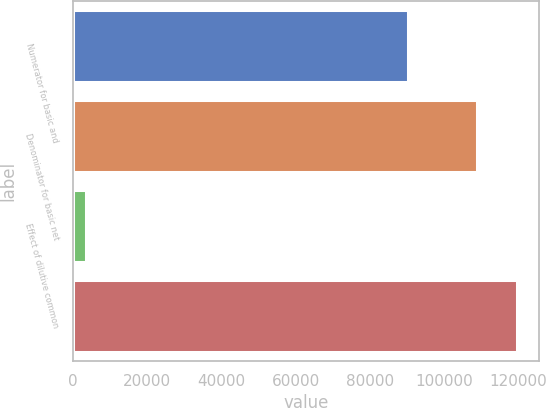Convert chart. <chart><loc_0><loc_0><loc_500><loc_500><bar_chart><fcel>Numerator for basic and<fcel>Denominator for basic net<fcel>Effect of dilutive common<fcel>Unnamed: 3<nl><fcel>90313<fcel>108815<fcel>3460<fcel>119696<nl></chart> 